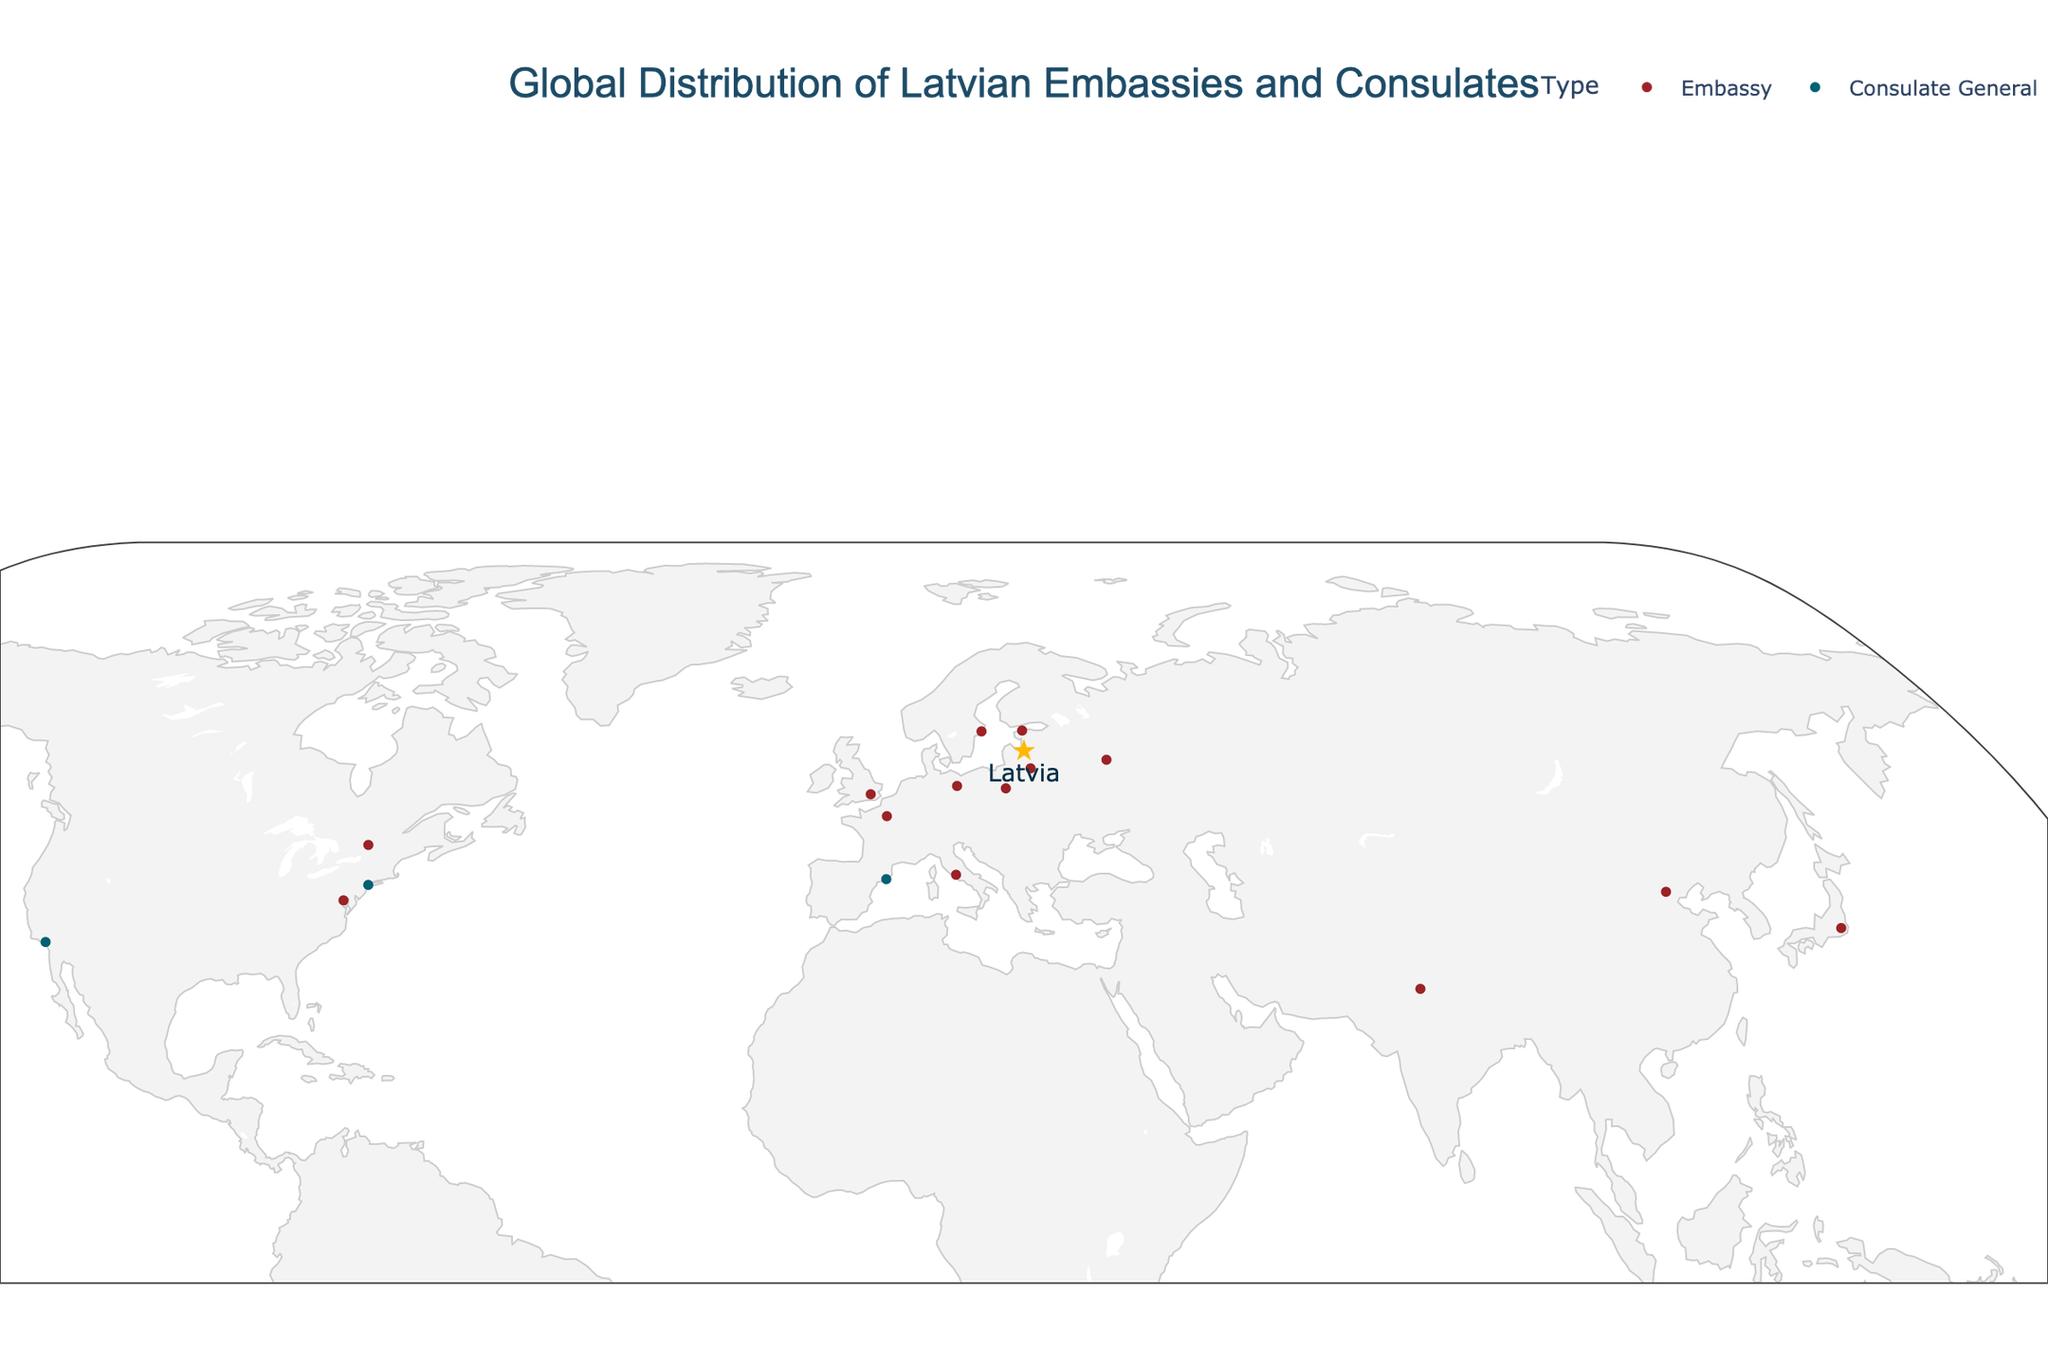What is the title of the figure? The title is located at the top of the figure and clearly states what the plot represents.
Answer: Global Distribution of Latvian Embassies and Consulates What color represents the Latvian embassies? The color legend indicates the specific color used for embassies.
Answer: #9B2226 (a shade of red) How many embassies are there in the data? By counting the dots and labels categorized as 'Embassy', we can determine the number of embassies.
Answer: 13 Which city has a Latvian Consulate General located at the lowest latitude? By looking at the latitude values for the Consulate Generals and picking the smallest latitude value, we find the lowest one.
Answer: Sydney How does the number of Latvian embassies compare to the number of consulates generally? Count the total embassies and compare it to the total consulates in the data.
Answer: Latvian embassies are more numerous than consulates (13 vs. 4) Which continent hosts the most Latvian embassies and consulates combined? Evaluate the distribution of locations based on continents by clustering the cities accordingly.
Answer: Europe What is the average longitude of Latvian embassies in Europe? Find the longitudes for European embassies, sum them, and divide by the number of embassies. (ex: Berlin, Paris, Rome, Warsaw, Tallinn, Vilnius, Stockholm, London)
Answer: (13.4050 + 2.3522 + 12.4964 + 21.0122 + 24.7536 + 25.2797 + 18.0686 + -0.1278) / 8 ≈ 14.78 Which embassy is located at the highest latitude? Compare the latitude values for all embassies and identify the highest one visually.
Answer: Stockholm How many Latvian consulates are there in the United States? Count the number of Consulate Generals specifically within the United States
Answer: Two (New York and Los Angeles) Which embassy is closest to the geographic center of Latvia (56.8796°N, 24.6032°E)? Calculate the Euclidean distance for each embassy's coordinates to Latvia’s center and find the minimum.
Answer: Tallinn 